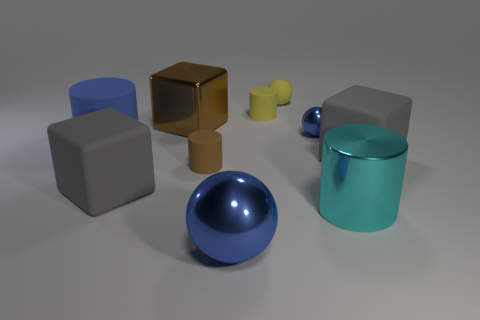There is a big blue rubber object; is its shape the same as the brown thing that is in front of the blue rubber object?
Your answer should be compact. Yes. What size is the rubber thing that is the same color as the metallic block?
Keep it short and to the point. Small. There is a gray object that is left of the large cyan thing; is its shape the same as the big brown metallic object?
Your answer should be very brief. Yes. What number of yellow rubber cylinders have the same size as the cyan shiny object?
Provide a succinct answer. 0. Is there a big matte cylinder that has the same color as the tiny metallic sphere?
Give a very brief answer. Yes. Does the cyan cylinder have the same material as the tiny blue ball?
Give a very brief answer. Yes. How many small blue things have the same shape as the brown matte object?
Provide a short and direct response. 0. What is the shape of the small thing that is the same material as the big ball?
Give a very brief answer. Sphere. What is the color of the metallic ball behind the tiny rubber cylinder in front of the big blue cylinder?
Your response must be concise. Blue. Does the tiny metal object have the same color as the large sphere?
Offer a terse response. Yes. 